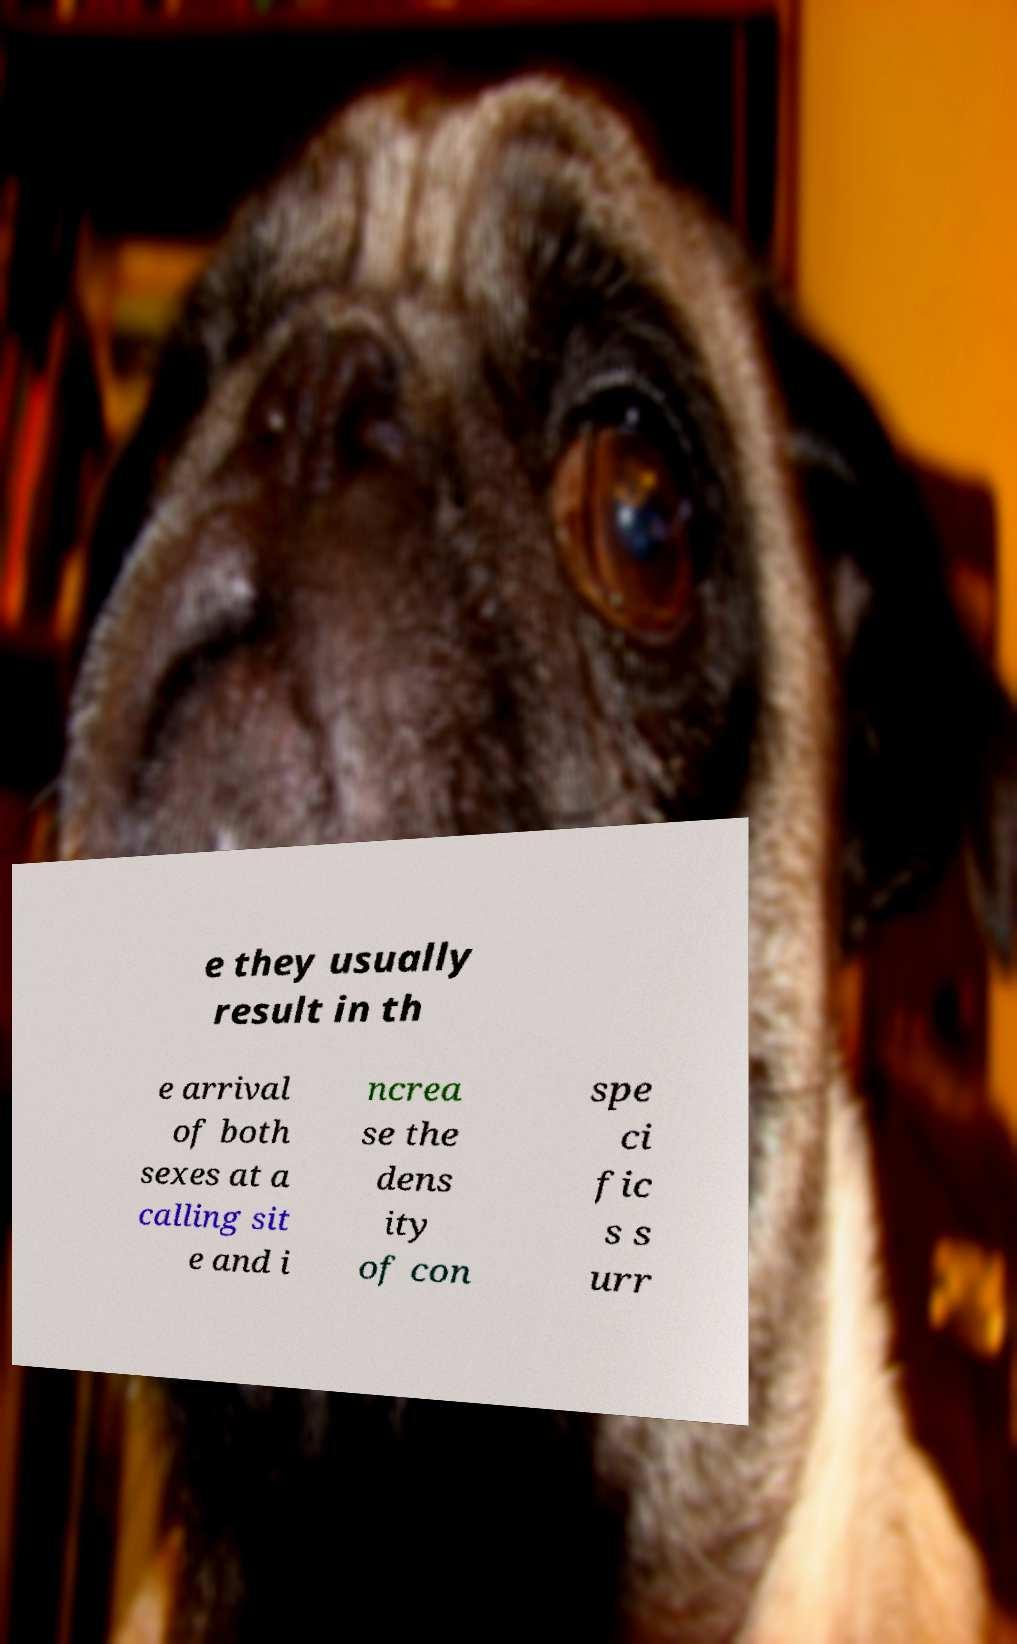Can you read and provide the text displayed in the image?This photo seems to have some interesting text. Can you extract and type it out for me? e they usually result in th e arrival of both sexes at a calling sit e and i ncrea se the dens ity of con spe ci fic s s urr 